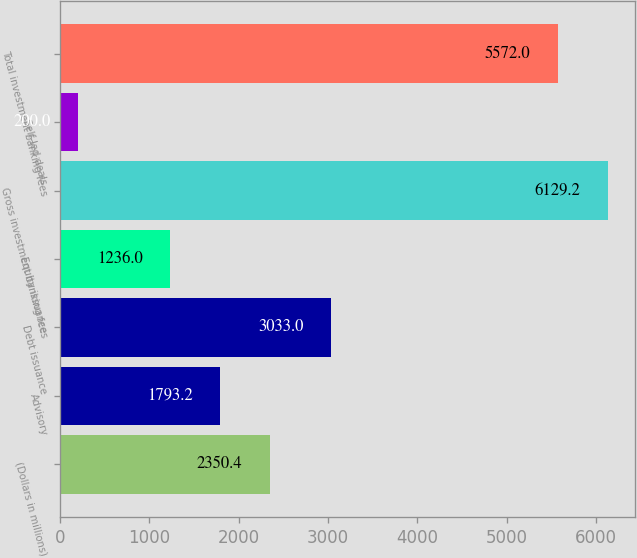Convert chart. <chart><loc_0><loc_0><loc_500><loc_500><bar_chart><fcel>(Dollars in millions)<fcel>Advisory<fcel>Debt issuance<fcel>Equity issuance<fcel>Gross investment banking fees<fcel>Self-led deals<fcel>Total investment banking fees<nl><fcel>2350.4<fcel>1793.2<fcel>3033<fcel>1236<fcel>6129.2<fcel>200<fcel>5572<nl></chart> 